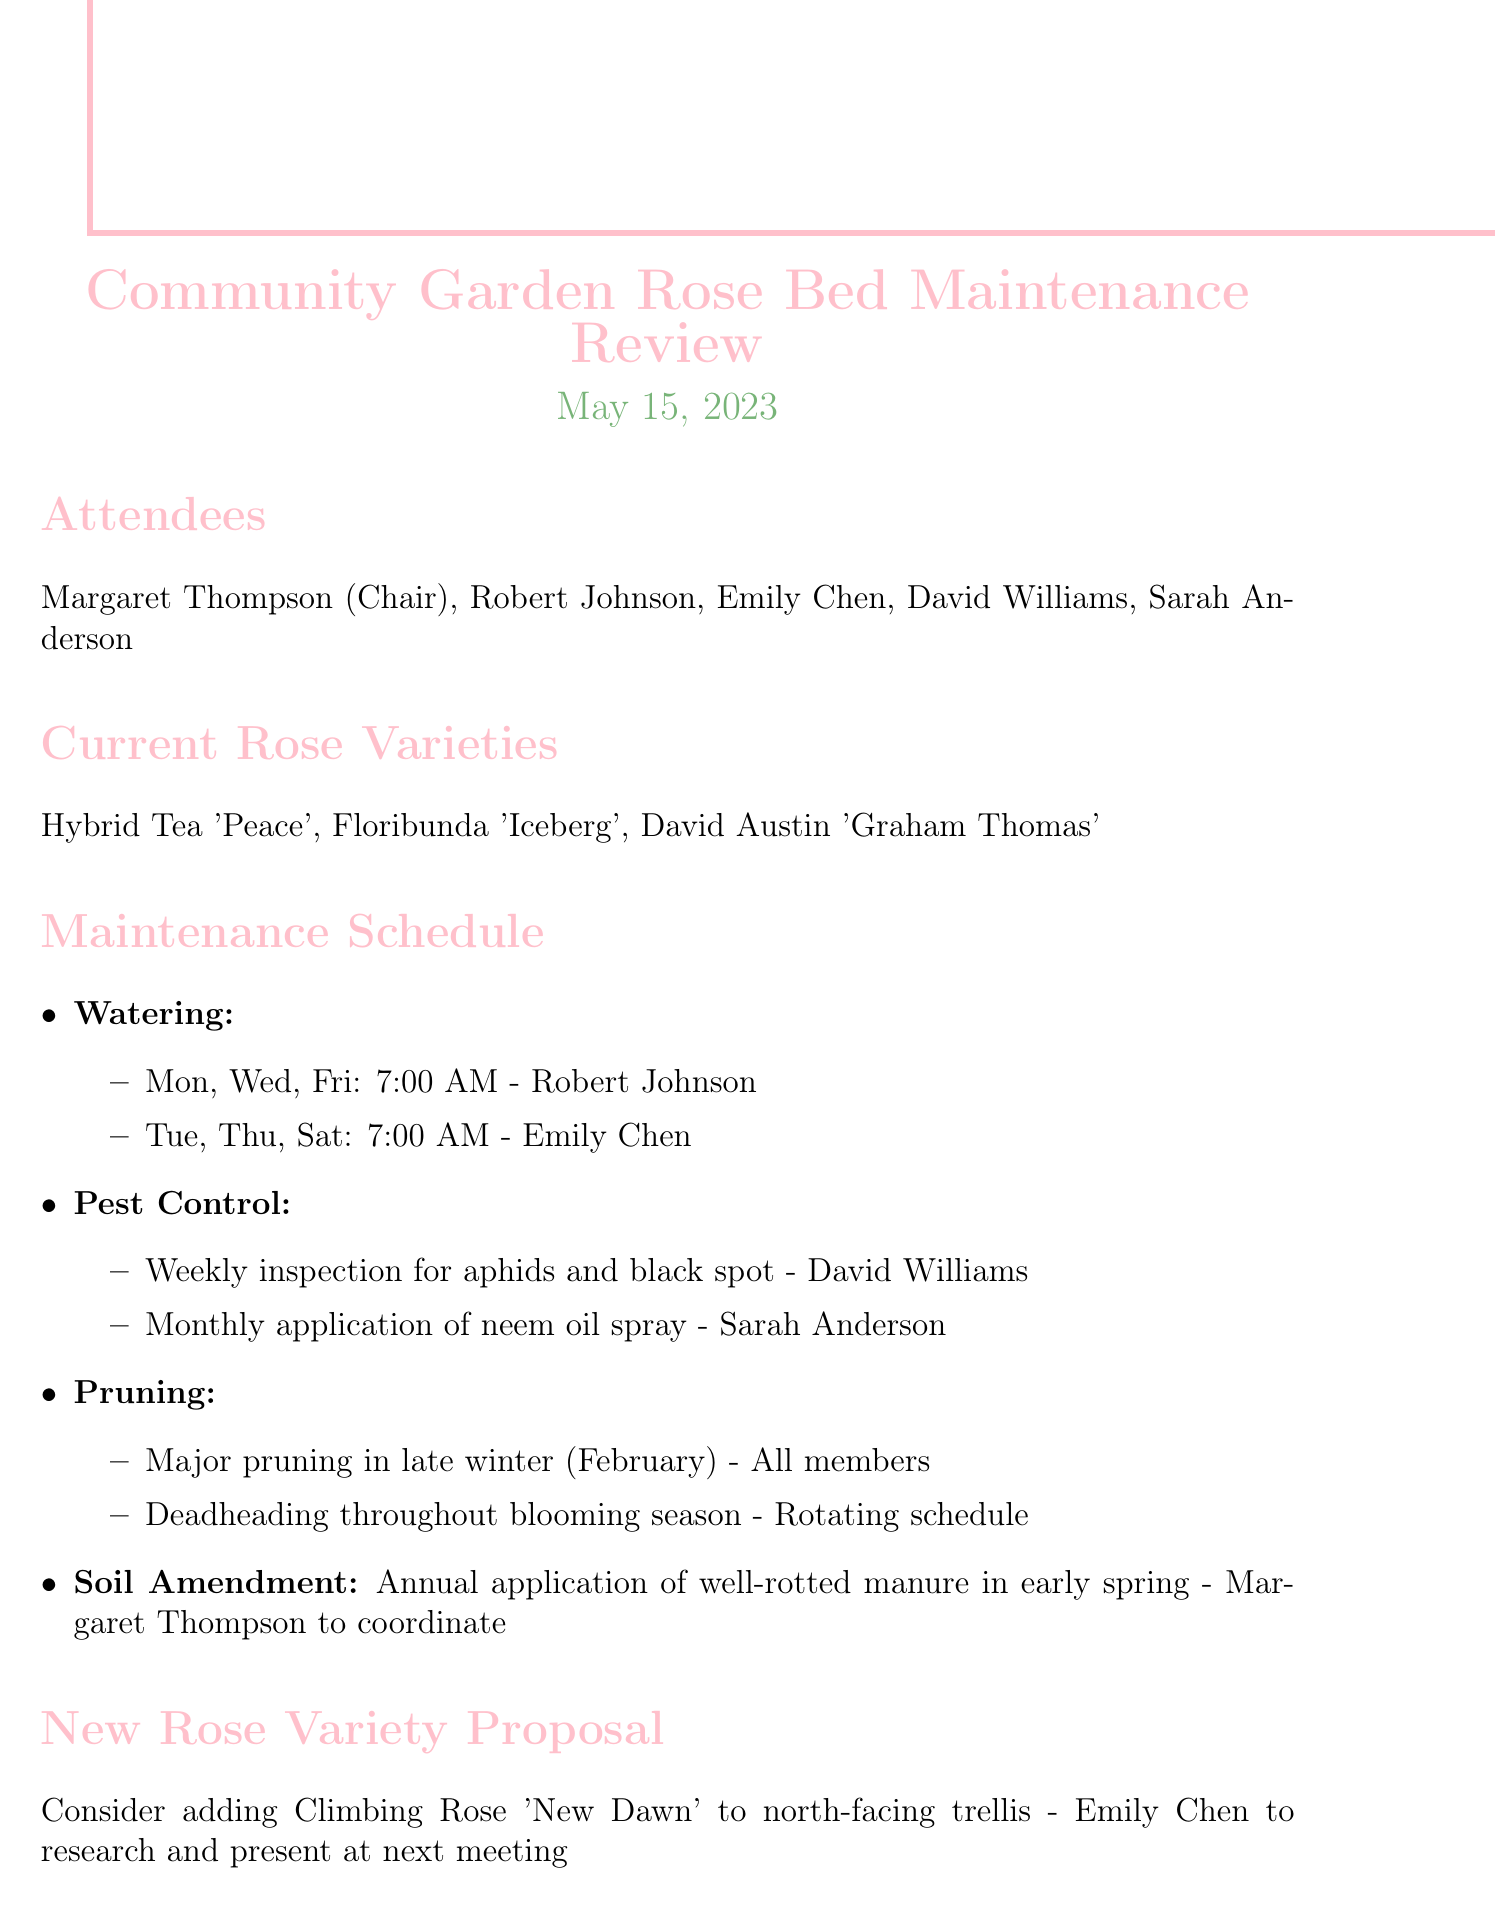What is the title of the meeting? The title of the meeting is stated at the top of the document as "Community Garden Rose Bed Maintenance Review."
Answer: Community Garden Rose Bed Maintenance Review Who chairs the meeting? The document lists Margaret Thompson as the chairperson in the attendees section.
Answer: Margaret Thompson What is the date of the meeting? The date is clearly mentioned in the header of the document.
Answer: May 15, 2023 Who is responsible for watering on Mondays, Wednesdays, and Fridays? The watering schedule specifies that Robert Johnson is responsible for these days.
Answer: Robert Johnson What pest is mentioned for weekly inspection? The documents state that aphids are specifically mentioned for weekly inspection under the pest control details.
Answer: aphids When is the next scheduled meeting? The date of the next meeting is provided in the last section of the document.
Answer: June 12, 2023 What type of rose is proposed to be added to the garden? The new rose variety proposal mentions "Climbing Rose 'New Dawn'."
Answer: Climbing Rose 'New Dawn' What is the role of Margaret Thompson in soil amendment? The document states that Margaret Thompson will coordinate the soil amendment, indicating her specific involvement.
Answer: to coordinate How often will pest control inspections be conducted? The pest control section explains that inspections will be done weekly.
Answer: weekly 